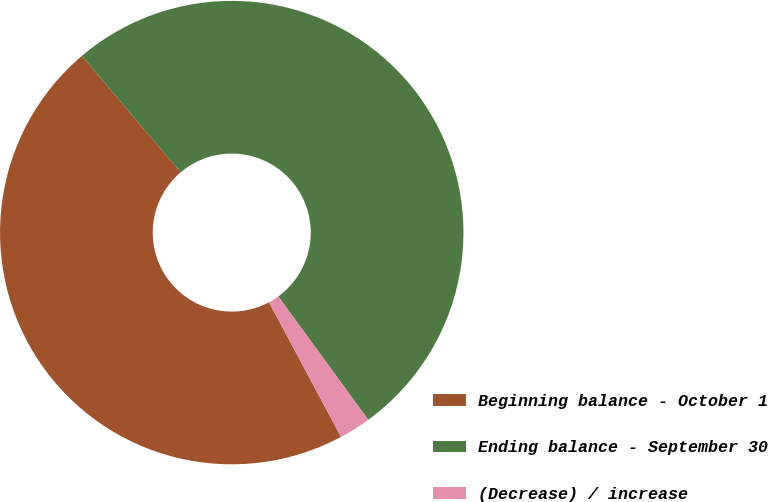<chart> <loc_0><loc_0><loc_500><loc_500><pie_chart><fcel>Beginning balance - October 1<fcel>Ending balance - September 30<fcel>(Decrease) / increase<nl><fcel>46.62%<fcel>51.17%<fcel>2.21%<nl></chart> 